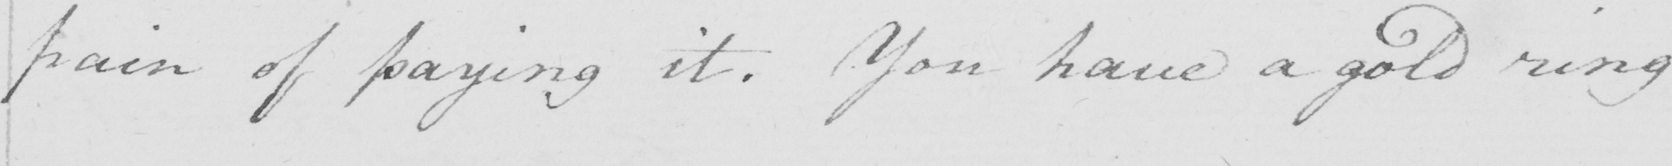Please transcribe the handwritten text in this image. pain of paying it . You have a gold ring 